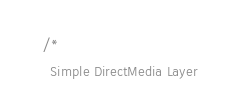<code> <loc_0><loc_0><loc_500><loc_500><_C_>/*
  Simple DirectMedia Layer</code> 